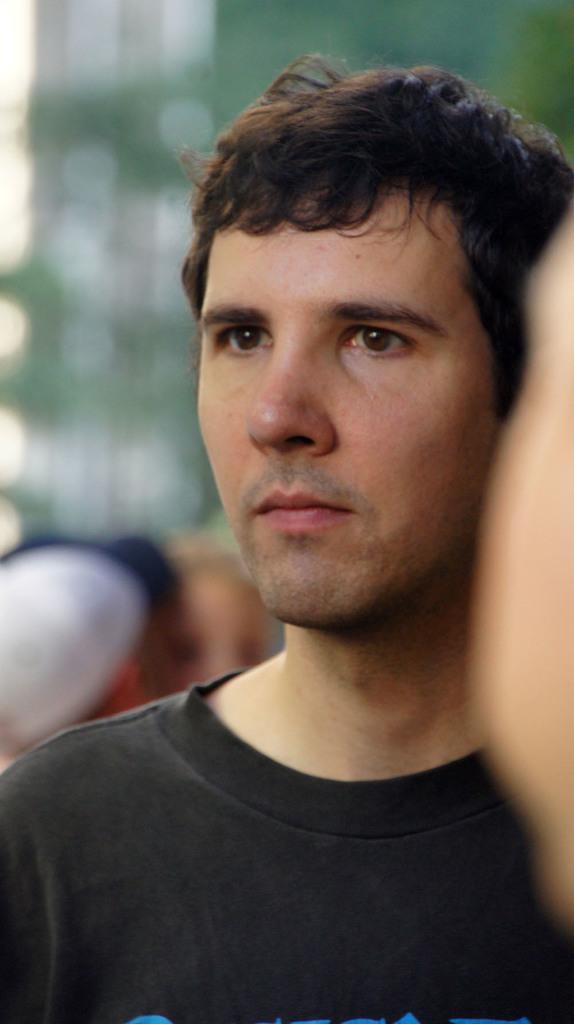How would you summarize this image in a sentence or two? In this picture i can see a man. The man is wearing a black color t shirt. The background of the image is blur. 